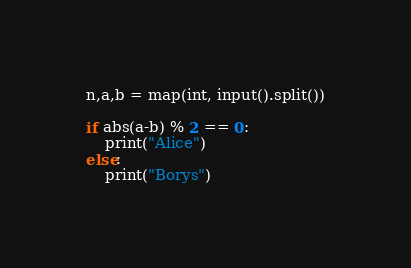Convert code to text. <code><loc_0><loc_0><loc_500><loc_500><_Python_>n,a,b = map(int, input().split())

if abs(a-b) % 2 == 0:
    print("Alice")
else:
    print("Borys")
</code> 